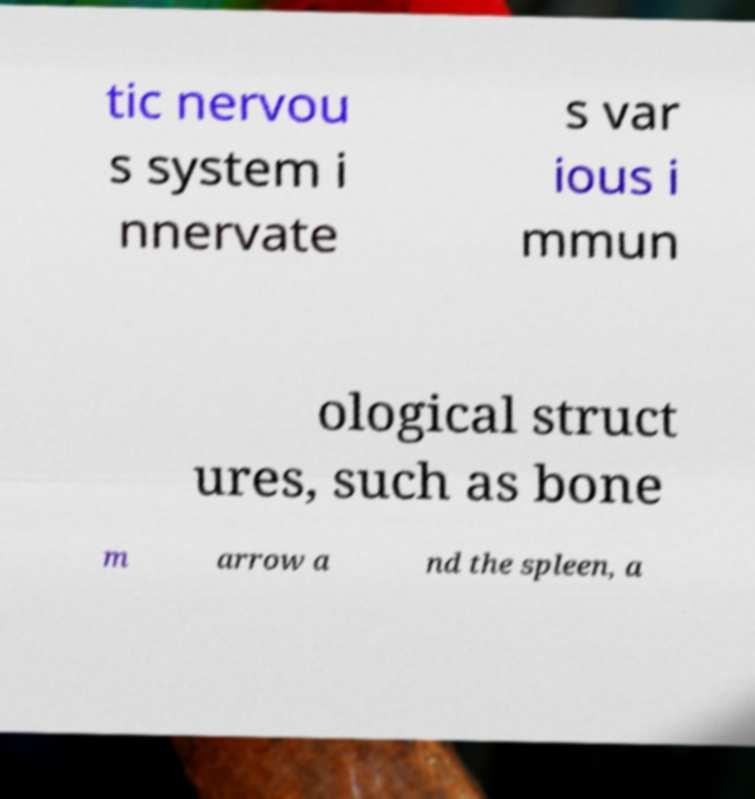Could you assist in decoding the text presented in this image and type it out clearly? tic nervou s system i nnervate s var ious i mmun ological struct ures, such as bone m arrow a nd the spleen, a 